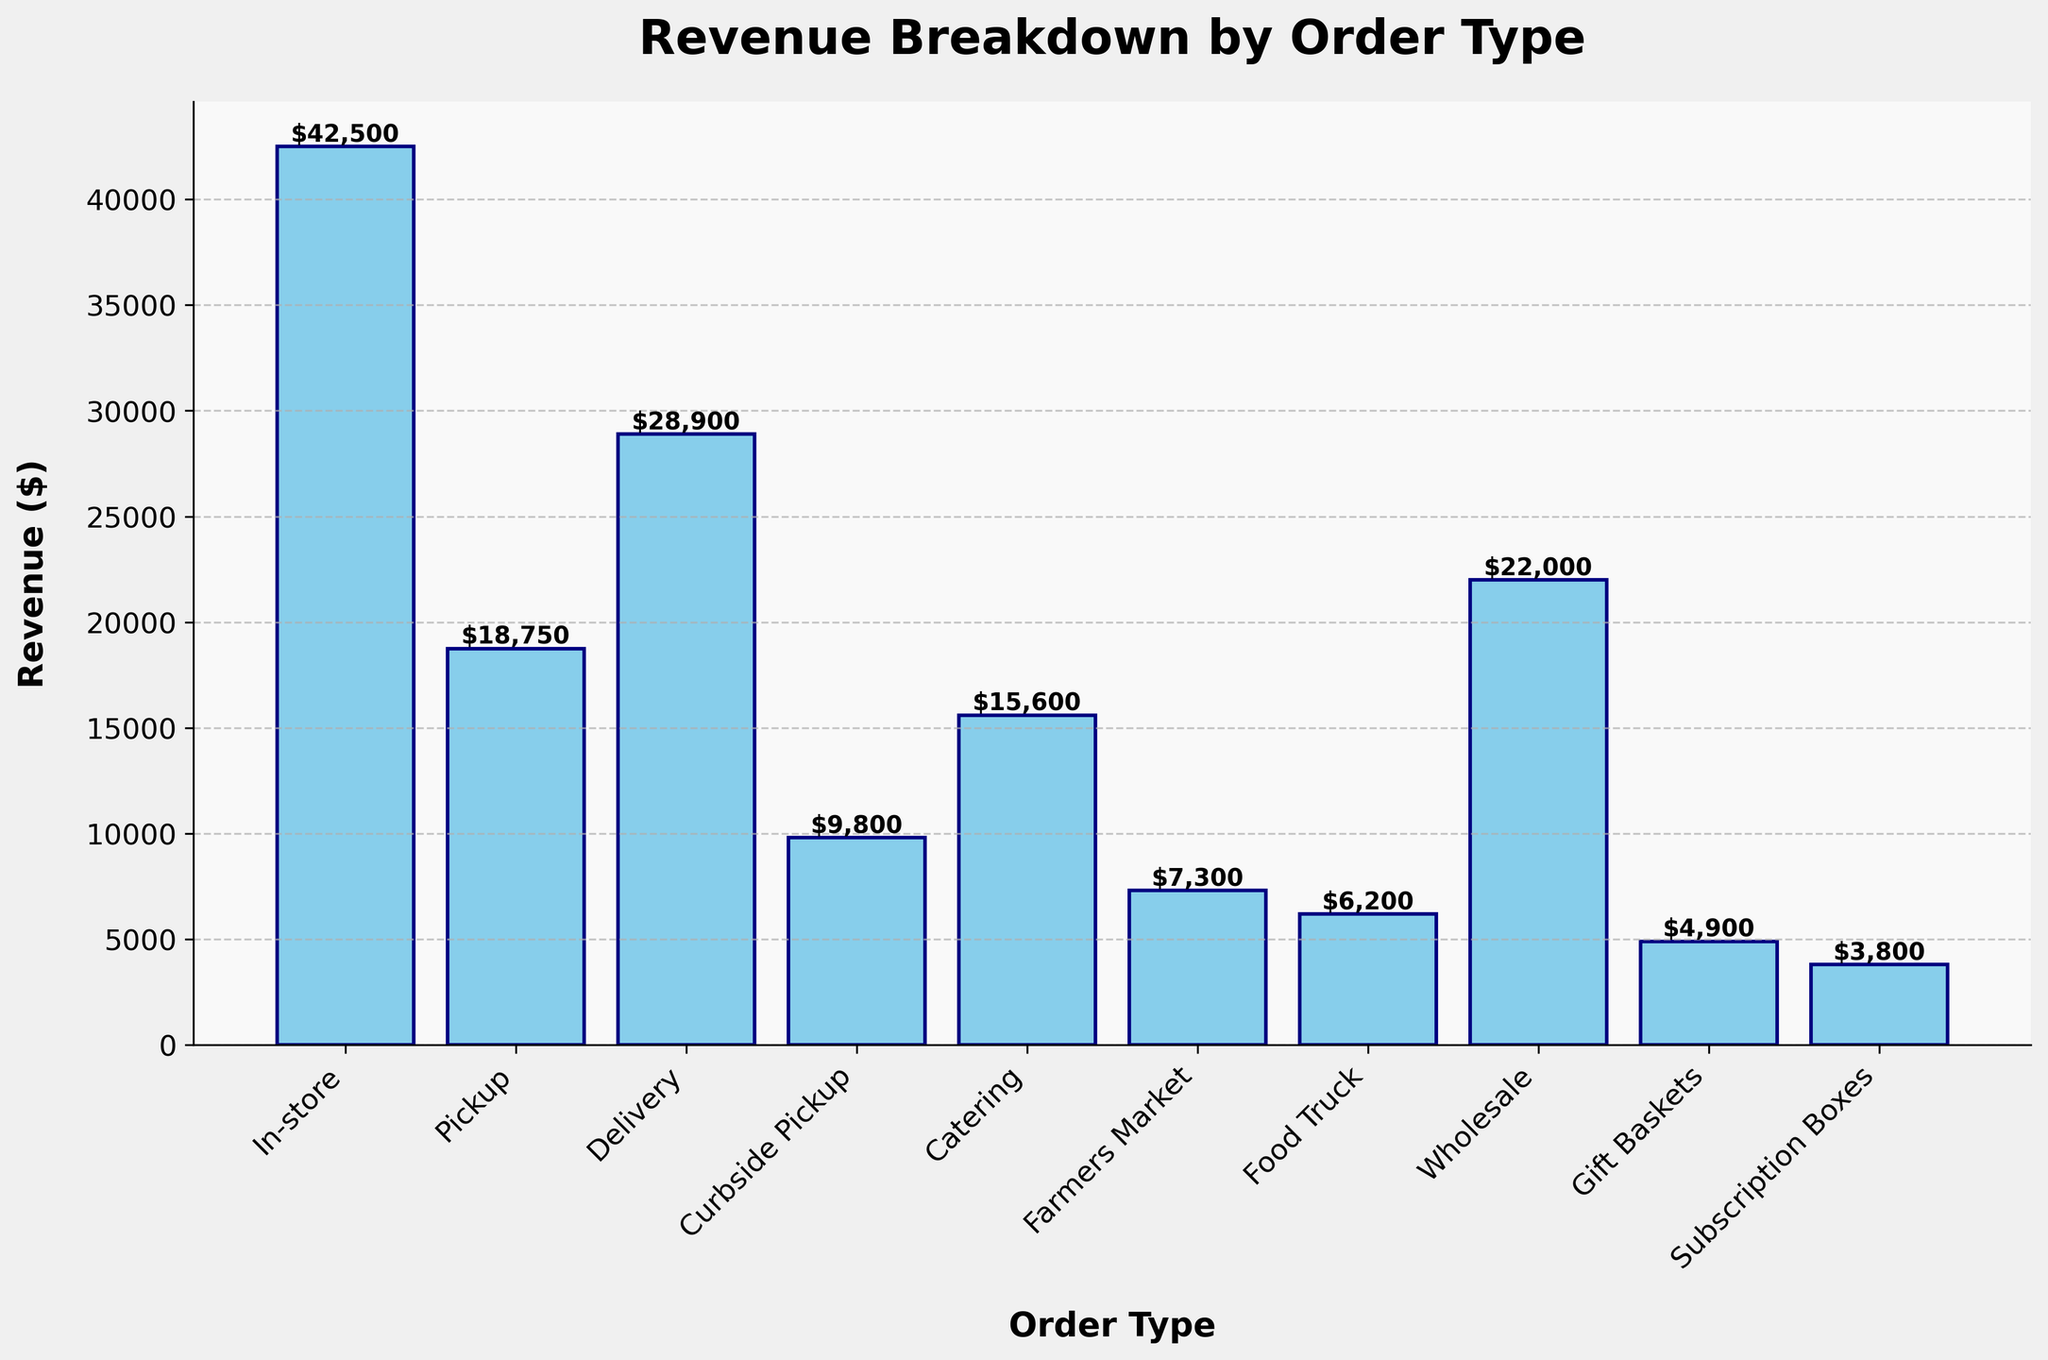Which order type generates the highest revenue? By observing the bar chart, the 'In-store' bar is the tallest, indicating it generates the highest revenue.
Answer: In-store What is the total revenue from Pickup and Delivery orders combined? To find the total revenue, add the revenues from 'Pickup' ($18,750) and 'Delivery' ($28,900). 18,750 + 28,900 = 47,650.
Answer: $47,650 Which has more revenue: Catering or Wholesale? By comparing the heights of the bars, 'Wholesale' has a taller bar than 'Catering', indicating higher revenue.
Answer: Wholesale What is the revenue difference between Curbside Pickup and Farmers Market? Subtract the revenue of 'Farmers Market' ($7,300) from 'Curbside Pickup' ($9,800). 9,800 - 7,300 = 2,500.
Answer: $2,500 Among Delivery, Gift Baskets, and Subscription Boxes, which has the lowest revenue? Comparing the 'Delivery', 'Gift Baskets', and 'Subscription Boxes' bars, 'Subscription Boxes' is the shortest, indicating the lowest revenue.
Answer: Subscription Boxes How much more revenue does In-store generate compared to Pickup? Subtract the revenue of 'Pickup' ($18,750) from 'In-store' ($42,500). 42,500 - 18,750 = 23,750.
Answer: $23,750 What is the average revenue of Farmers Market, Food Truck, and Wholesale? Add the revenues of 'Farmers Market' ($7,300), 'Food Truck' ($6,200), and 'Wholesale' ($22,000) and divide by 3. (7,300 + 6,200 + 22,000) / 3 = 11,833.33.
Answer: $11,833.33 Rank the following order types by revenue from highest to lowest: In-store, Pickup, Delivery, Curbside Pickup. By observing the heights of their bars, they rank as follows: In-store ($42,500), Delivery ($28,900), Pickup ($18,750), Curbside Pickup ($9,800).
Answer: In-store, Delivery, Pickup, Curbside Pickup Does Catering generate more revenue than Farmers Market and Food Truck combined? Add the revenues of 'Farmers Market' ($7,300) and 'Food Truck' ($6,200). 7,300 + 6,200 = 13,500. Since $15,600 (Catering) > $13,500, Catering generates more revenue.
Answer: Yes 